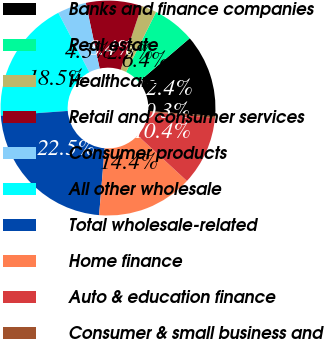<chart> <loc_0><loc_0><loc_500><loc_500><pie_chart><fcel>Banks and finance companies<fcel>Real estate<fcel>Healthcare<fcel>Retail and consumer services<fcel>Consumer products<fcel>All other wholesale<fcel>Total wholesale-related<fcel>Home finance<fcel>Auto & education finance<fcel>Consumer & small business and<nl><fcel>12.43%<fcel>6.36%<fcel>2.32%<fcel>8.38%<fcel>4.34%<fcel>18.49%<fcel>22.54%<fcel>14.45%<fcel>10.4%<fcel>0.29%<nl></chart> 